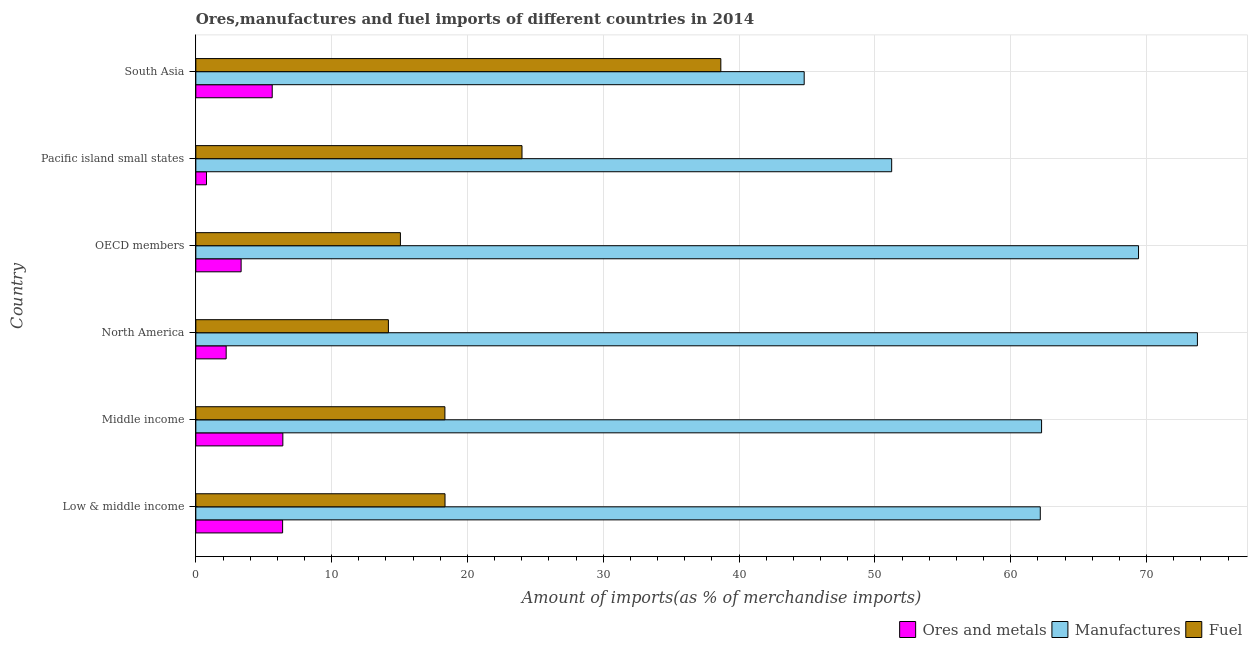How many different coloured bars are there?
Your answer should be very brief. 3. What is the percentage of fuel imports in Pacific island small states?
Your answer should be very brief. 24.01. Across all countries, what is the maximum percentage of ores and metals imports?
Offer a very short reply. 6.41. Across all countries, what is the minimum percentage of ores and metals imports?
Provide a short and direct response. 0.79. In which country was the percentage of manufactures imports minimum?
Provide a short and direct response. South Asia. What is the total percentage of ores and metals imports in the graph?
Make the answer very short. 24.77. What is the difference between the percentage of fuel imports in North America and that in South Asia?
Make the answer very short. -24.48. What is the difference between the percentage of manufactures imports in Middle income and the percentage of ores and metals imports in Low & middle income?
Your response must be concise. 55.88. What is the average percentage of manufactures imports per country?
Keep it short and to the point. 60.6. What is the difference between the percentage of ores and metals imports and percentage of fuel imports in South Asia?
Provide a succinct answer. -33.03. In how many countries, is the percentage of manufactures imports greater than 66 %?
Provide a short and direct response. 2. What is the ratio of the percentage of manufactures imports in Middle income to that in Pacific island small states?
Keep it short and to the point. 1.22. Is the percentage of fuel imports in Low & middle income less than that in OECD members?
Make the answer very short. No. What is the difference between the highest and the second highest percentage of manufactures imports?
Your answer should be very brief. 4.33. What is the difference between the highest and the lowest percentage of fuel imports?
Give a very brief answer. 24.47. Is the sum of the percentage of fuel imports in North America and OECD members greater than the maximum percentage of ores and metals imports across all countries?
Keep it short and to the point. Yes. What does the 2nd bar from the top in OECD members represents?
Ensure brevity in your answer.  Manufactures. What does the 3rd bar from the bottom in Pacific island small states represents?
Keep it short and to the point. Fuel. Is it the case that in every country, the sum of the percentage of ores and metals imports and percentage of manufactures imports is greater than the percentage of fuel imports?
Provide a short and direct response. Yes. How many bars are there?
Provide a succinct answer. 18. Are all the bars in the graph horizontal?
Make the answer very short. Yes. How many countries are there in the graph?
Provide a short and direct response. 6. Are the values on the major ticks of X-axis written in scientific E-notation?
Give a very brief answer. No. Does the graph contain grids?
Your answer should be very brief. Yes. How many legend labels are there?
Your answer should be compact. 3. How are the legend labels stacked?
Your response must be concise. Horizontal. What is the title of the graph?
Give a very brief answer. Ores,manufactures and fuel imports of different countries in 2014. Does "Social Protection and Labor" appear as one of the legend labels in the graph?
Give a very brief answer. No. What is the label or title of the X-axis?
Offer a very short reply. Amount of imports(as % of merchandise imports). What is the Amount of imports(as % of merchandise imports) in Ores and metals in Low & middle income?
Give a very brief answer. 6.39. What is the Amount of imports(as % of merchandise imports) in Manufactures in Low & middle income?
Give a very brief answer. 62.17. What is the Amount of imports(as % of merchandise imports) of Fuel in Low & middle income?
Ensure brevity in your answer.  18.35. What is the Amount of imports(as % of merchandise imports) of Ores and metals in Middle income?
Offer a terse response. 6.41. What is the Amount of imports(as % of merchandise imports) of Manufactures in Middle income?
Offer a very short reply. 62.27. What is the Amount of imports(as % of merchandise imports) in Fuel in Middle income?
Your answer should be very brief. 18.34. What is the Amount of imports(as % of merchandise imports) in Ores and metals in North America?
Provide a short and direct response. 2.23. What is the Amount of imports(as % of merchandise imports) of Manufactures in North America?
Your answer should be very brief. 73.74. What is the Amount of imports(as % of merchandise imports) in Fuel in North America?
Your response must be concise. 14.18. What is the Amount of imports(as % of merchandise imports) in Ores and metals in OECD members?
Offer a terse response. 3.33. What is the Amount of imports(as % of merchandise imports) of Manufactures in OECD members?
Your response must be concise. 69.41. What is the Amount of imports(as % of merchandise imports) in Fuel in OECD members?
Your response must be concise. 15.06. What is the Amount of imports(as % of merchandise imports) of Ores and metals in Pacific island small states?
Your answer should be compact. 0.79. What is the Amount of imports(as % of merchandise imports) of Manufactures in Pacific island small states?
Provide a succinct answer. 51.23. What is the Amount of imports(as % of merchandise imports) in Fuel in Pacific island small states?
Ensure brevity in your answer.  24.01. What is the Amount of imports(as % of merchandise imports) in Ores and metals in South Asia?
Make the answer very short. 5.62. What is the Amount of imports(as % of merchandise imports) of Manufactures in South Asia?
Ensure brevity in your answer.  44.79. What is the Amount of imports(as % of merchandise imports) of Fuel in South Asia?
Your answer should be compact. 38.65. Across all countries, what is the maximum Amount of imports(as % of merchandise imports) of Ores and metals?
Your answer should be compact. 6.41. Across all countries, what is the maximum Amount of imports(as % of merchandise imports) in Manufactures?
Offer a terse response. 73.74. Across all countries, what is the maximum Amount of imports(as % of merchandise imports) of Fuel?
Your answer should be compact. 38.65. Across all countries, what is the minimum Amount of imports(as % of merchandise imports) in Ores and metals?
Provide a short and direct response. 0.79. Across all countries, what is the minimum Amount of imports(as % of merchandise imports) of Manufactures?
Your answer should be very brief. 44.79. Across all countries, what is the minimum Amount of imports(as % of merchandise imports) of Fuel?
Your response must be concise. 14.18. What is the total Amount of imports(as % of merchandise imports) in Ores and metals in the graph?
Ensure brevity in your answer.  24.77. What is the total Amount of imports(as % of merchandise imports) of Manufactures in the graph?
Your answer should be very brief. 363.6. What is the total Amount of imports(as % of merchandise imports) in Fuel in the graph?
Give a very brief answer. 128.59. What is the difference between the Amount of imports(as % of merchandise imports) in Ores and metals in Low & middle income and that in Middle income?
Keep it short and to the point. -0.02. What is the difference between the Amount of imports(as % of merchandise imports) of Manufactures in Low & middle income and that in Middle income?
Provide a succinct answer. -0.1. What is the difference between the Amount of imports(as % of merchandise imports) of Fuel in Low & middle income and that in Middle income?
Your response must be concise. 0.01. What is the difference between the Amount of imports(as % of merchandise imports) of Ores and metals in Low & middle income and that in North America?
Your answer should be compact. 4.15. What is the difference between the Amount of imports(as % of merchandise imports) of Manufactures in Low & middle income and that in North America?
Offer a very short reply. -11.57. What is the difference between the Amount of imports(as % of merchandise imports) in Fuel in Low & middle income and that in North America?
Provide a succinct answer. 4.17. What is the difference between the Amount of imports(as % of merchandise imports) of Ores and metals in Low & middle income and that in OECD members?
Offer a very short reply. 3.05. What is the difference between the Amount of imports(as % of merchandise imports) in Manufactures in Low & middle income and that in OECD members?
Make the answer very short. -7.23. What is the difference between the Amount of imports(as % of merchandise imports) of Fuel in Low & middle income and that in OECD members?
Your answer should be very brief. 3.28. What is the difference between the Amount of imports(as % of merchandise imports) in Ores and metals in Low & middle income and that in Pacific island small states?
Provide a short and direct response. 5.6. What is the difference between the Amount of imports(as % of merchandise imports) of Manufactures in Low & middle income and that in Pacific island small states?
Provide a short and direct response. 10.94. What is the difference between the Amount of imports(as % of merchandise imports) of Fuel in Low & middle income and that in Pacific island small states?
Provide a short and direct response. -5.67. What is the difference between the Amount of imports(as % of merchandise imports) in Ores and metals in Low & middle income and that in South Asia?
Offer a terse response. 0.76. What is the difference between the Amount of imports(as % of merchandise imports) of Manufactures in Low & middle income and that in South Asia?
Provide a short and direct response. 17.38. What is the difference between the Amount of imports(as % of merchandise imports) of Fuel in Low & middle income and that in South Asia?
Provide a short and direct response. -20.31. What is the difference between the Amount of imports(as % of merchandise imports) in Ores and metals in Middle income and that in North America?
Provide a short and direct response. 4.17. What is the difference between the Amount of imports(as % of merchandise imports) of Manufactures in Middle income and that in North America?
Your answer should be very brief. -11.47. What is the difference between the Amount of imports(as % of merchandise imports) of Fuel in Middle income and that in North America?
Your response must be concise. 4.16. What is the difference between the Amount of imports(as % of merchandise imports) of Ores and metals in Middle income and that in OECD members?
Keep it short and to the point. 3.07. What is the difference between the Amount of imports(as % of merchandise imports) of Manufactures in Middle income and that in OECD members?
Offer a terse response. -7.14. What is the difference between the Amount of imports(as % of merchandise imports) in Fuel in Middle income and that in OECD members?
Make the answer very short. 3.28. What is the difference between the Amount of imports(as % of merchandise imports) in Ores and metals in Middle income and that in Pacific island small states?
Ensure brevity in your answer.  5.62. What is the difference between the Amount of imports(as % of merchandise imports) in Manufactures in Middle income and that in Pacific island small states?
Give a very brief answer. 11.04. What is the difference between the Amount of imports(as % of merchandise imports) of Fuel in Middle income and that in Pacific island small states?
Your response must be concise. -5.68. What is the difference between the Amount of imports(as % of merchandise imports) in Ores and metals in Middle income and that in South Asia?
Make the answer very short. 0.78. What is the difference between the Amount of imports(as % of merchandise imports) of Manufactures in Middle income and that in South Asia?
Give a very brief answer. 17.48. What is the difference between the Amount of imports(as % of merchandise imports) in Fuel in Middle income and that in South Asia?
Your answer should be very brief. -20.31. What is the difference between the Amount of imports(as % of merchandise imports) in Ores and metals in North America and that in OECD members?
Make the answer very short. -1.1. What is the difference between the Amount of imports(as % of merchandise imports) of Manufactures in North America and that in OECD members?
Your answer should be compact. 4.33. What is the difference between the Amount of imports(as % of merchandise imports) of Fuel in North America and that in OECD members?
Make the answer very short. -0.88. What is the difference between the Amount of imports(as % of merchandise imports) in Ores and metals in North America and that in Pacific island small states?
Offer a very short reply. 1.45. What is the difference between the Amount of imports(as % of merchandise imports) in Manufactures in North America and that in Pacific island small states?
Make the answer very short. 22.51. What is the difference between the Amount of imports(as % of merchandise imports) in Fuel in North America and that in Pacific island small states?
Provide a succinct answer. -9.84. What is the difference between the Amount of imports(as % of merchandise imports) in Ores and metals in North America and that in South Asia?
Keep it short and to the point. -3.39. What is the difference between the Amount of imports(as % of merchandise imports) in Manufactures in North America and that in South Asia?
Provide a short and direct response. 28.95. What is the difference between the Amount of imports(as % of merchandise imports) in Fuel in North America and that in South Asia?
Provide a short and direct response. -24.47. What is the difference between the Amount of imports(as % of merchandise imports) of Ores and metals in OECD members and that in Pacific island small states?
Keep it short and to the point. 2.55. What is the difference between the Amount of imports(as % of merchandise imports) of Manufactures in OECD members and that in Pacific island small states?
Your answer should be compact. 18.18. What is the difference between the Amount of imports(as % of merchandise imports) in Fuel in OECD members and that in Pacific island small states?
Your answer should be very brief. -8.95. What is the difference between the Amount of imports(as % of merchandise imports) of Ores and metals in OECD members and that in South Asia?
Provide a succinct answer. -2.29. What is the difference between the Amount of imports(as % of merchandise imports) in Manufactures in OECD members and that in South Asia?
Your answer should be very brief. 24.62. What is the difference between the Amount of imports(as % of merchandise imports) of Fuel in OECD members and that in South Asia?
Keep it short and to the point. -23.59. What is the difference between the Amount of imports(as % of merchandise imports) of Ores and metals in Pacific island small states and that in South Asia?
Your answer should be compact. -4.84. What is the difference between the Amount of imports(as % of merchandise imports) in Manufactures in Pacific island small states and that in South Asia?
Your answer should be very brief. 6.44. What is the difference between the Amount of imports(as % of merchandise imports) in Fuel in Pacific island small states and that in South Asia?
Provide a succinct answer. -14.64. What is the difference between the Amount of imports(as % of merchandise imports) in Ores and metals in Low & middle income and the Amount of imports(as % of merchandise imports) in Manufactures in Middle income?
Offer a very short reply. -55.88. What is the difference between the Amount of imports(as % of merchandise imports) in Ores and metals in Low & middle income and the Amount of imports(as % of merchandise imports) in Fuel in Middle income?
Your answer should be very brief. -11.95. What is the difference between the Amount of imports(as % of merchandise imports) of Manufactures in Low & middle income and the Amount of imports(as % of merchandise imports) of Fuel in Middle income?
Your response must be concise. 43.83. What is the difference between the Amount of imports(as % of merchandise imports) of Ores and metals in Low & middle income and the Amount of imports(as % of merchandise imports) of Manufactures in North America?
Offer a very short reply. -67.35. What is the difference between the Amount of imports(as % of merchandise imports) in Ores and metals in Low & middle income and the Amount of imports(as % of merchandise imports) in Fuel in North America?
Provide a succinct answer. -7.79. What is the difference between the Amount of imports(as % of merchandise imports) in Manufactures in Low & middle income and the Amount of imports(as % of merchandise imports) in Fuel in North America?
Provide a succinct answer. 47.99. What is the difference between the Amount of imports(as % of merchandise imports) of Ores and metals in Low & middle income and the Amount of imports(as % of merchandise imports) of Manufactures in OECD members?
Your answer should be very brief. -63.02. What is the difference between the Amount of imports(as % of merchandise imports) of Ores and metals in Low & middle income and the Amount of imports(as % of merchandise imports) of Fuel in OECD members?
Keep it short and to the point. -8.67. What is the difference between the Amount of imports(as % of merchandise imports) of Manufactures in Low & middle income and the Amount of imports(as % of merchandise imports) of Fuel in OECD members?
Give a very brief answer. 47.11. What is the difference between the Amount of imports(as % of merchandise imports) in Ores and metals in Low & middle income and the Amount of imports(as % of merchandise imports) in Manufactures in Pacific island small states?
Your answer should be compact. -44.84. What is the difference between the Amount of imports(as % of merchandise imports) of Ores and metals in Low & middle income and the Amount of imports(as % of merchandise imports) of Fuel in Pacific island small states?
Keep it short and to the point. -17.63. What is the difference between the Amount of imports(as % of merchandise imports) in Manufactures in Low & middle income and the Amount of imports(as % of merchandise imports) in Fuel in Pacific island small states?
Your answer should be compact. 38.16. What is the difference between the Amount of imports(as % of merchandise imports) in Ores and metals in Low & middle income and the Amount of imports(as % of merchandise imports) in Manufactures in South Asia?
Keep it short and to the point. -38.4. What is the difference between the Amount of imports(as % of merchandise imports) of Ores and metals in Low & middle income and the Amount of imports(as % of merchandise imports) of Fuel in South Asia?
Offer a terse response. -32.26. What is the difference between the Amount of imports(as % of merchandise imports) of Manufactures in Low & middle income and the Amount of imports(as % of merchandise imports) of Fuel in South Asia?
Make the answer very short. 23.52. What is the difference between the Amount of imports(as % of merchandise imports) in Ores and metals in Middle income and the Amount of imports(as % of merchandise imports) in Manufactures in North America?
Offer a very short reply. -67.33. What is the difference between the Amount of imports(as % of merchandise imports) of Ores and metals in Middle income and the Amount of imports(as % of merchandise imports) of Fuel in North America?
Ensure brevity in your answer.  -7.77. What is the difference between the Amount of imports(as % of merchandise imports) of Manufactures in Middle income and the Amount of imports(as % of merchandise imports) of Fuel in North America?
Offer a very short reply. 48.09. What is the difference between the Amount of imports(as % of merchandise imports) in Ores and metals in Middle income and the Amount of imports(as % of merchandise imports) in Manufactures in OECD members?
Make the answer very short. -63. What is the difference between the Amount of imports(as % of merchandise imports) in Ores and metals in Middle income and the Amount of imports(as % of merchandise imports) in Fuel in OECD members?
Provide a short and direct response. -8.66. What is the difference between the Amount of imports(as % of merchandise imports) in Manufactures in Middle income and the Amount of imports(as % of merchandise imports) in Fuel in OECD members?
Your response must be concise. 47.21. What is the difference between the Amount of imports(as % of merchandise imports) in Ores and metals in Middle income and the Amount of imports(as % of merchandise imports) in Manufactures in Pacific island small states?
Your answer should be compact. -44.82. What is the difference between the Amount of imports(as % of merchandise imports) in Ores and metals in Middle income and the Amount of imports(as % of merchandise imports) in Fuel in Pacific island small states?
Offer a very short reply. -17.61. What is the difference between the Amount of imports(as % of merchandise imports) of Manufactures in Middle income and the Amount of imports(as % of merchandise imports) of Fuel in Pacific island small states?
Offer a terse response. 38.25. What is the difference between the Amount of imports(as % of merchandise imports) of Ores and metals in Middle income and the Amount of imports(as % of merchandise imports) of Manufactures in South Asia?
Offer a very short reply. -38.38. What is the difference between the Amount of imports(as % of merchandise imports) in Ores and metals in Middle income and the Amount of imports(as % of merchandise imports) in Fuel in South Asia?
Provide a succinct answer. -32.25. What is the difference between the Amount of imports(as % of merchandise imports) of Manufactures in Middle income and the Amount of imports(as % of merchandise imports) of Fuel in South Asia?
Give a very brief answer. 23.61. What is the difference between the Amount of imports(as % of merchandise imports) of Ores and metals in North America and the Amount of imports(as % of merchandise imports) of Manufactures in OECD members?
Make the answer very short. -67.17. What is the difference between the Amount of imports(as % of merchandise imports) of Ores and metals in North America and the Amount of imports(as % of merchandise imports) of Fuel in OECD members?
Offer a very short reply. -12.83. What is the difference between the Amount of imports(as % of merchandise imports) of Manufactures in North America and the Amount of imports(as % of merchandise imports) of Fuel in OECD members?
Your answer should be compact. 58.68. What is the difference between the Amount of imports(as % of merchandise imports) of Ores and metals in North America and the Amount of imports(as % of merchandise imports) of Manufactures in Pacific island small states?
Make the answer very short. -49. What is the difference between the Amount of imports(as % of merchandise imports) in Ores and metals in North America and the Amount of imports(as % of merchandise imports) in Fuel in Pacific island small states?
Offer a terse response. -21.78. What is the difference between the Amount of imports(as % of merchandise imports) in Manufactures in North America and the Amount of imports(as % of merchandise imports) in Fuel in Pacific island small states?
Make the answer very short. 49.73. What is the difference between the Amount of imports(as % of merchandise imports) of Ores and metals in North America and the Amount of imports(as % of merchandise imports) of Manufactures in South Asia?
Your answer should be compact. -42.56. What is the difference between the Amount of imports(as % of merchandise imports) of Ores and metals in North America and the Amount of imports(as % of merchandise imports) of Fuel in South Asia?
Make the answer very short. -36.42. What is the difference between the Amount of imports(as % of merchandise imports) of Manufactures in North America and the Amount of imports(as % of merchandise imports) of Fuel in South Asia?
Offer a terse response. 35.09. What is the difference between the Amount of imports(as % of merchandise imports) of Ores and metals in OECD members and the Amount of imports(as % of merchandise imports) of Manufactures in Pacific island small states?
Provide a succinct answer. -47.9. What is the difference between the Amount of imports(as % of merchandise imports) in Ores and metals in OECD members and the Amount of imports(as % of merchandise imports) in Fuel in Pacific island small states?
Offer a terse response. -20.68. What is the difference between the Amount of imports(as % of merchandise imports) in Manufactures in OECD members and the Amount of imports(as % of merchandise imports) in Fuel in Pacific island small states?
Ensure brevity in your answer.  45.39. What is the difference between the Amount of imports(as % of merchandise imports) of Ores and metals in OECD members and the Amount of imports(as % of merchandise imports) of Manufactures in South Asia?
Ensure brevity in your answer.  -41.45. What is the difference between the Amount of imports(as % of merchandise imports) of Ores and metals in OECD members and the Amount of imports(as % of merchandise imports) of Fuel in South Asia?
Make the answer very short. -35.32. What is the difference between the Amount of imports(as % of merchandise imports) in Manufactures in OECD members and the Amount of imports(as % of merchandise imports) in Fuel in South Asia?
Offer a very short reply. 30.75. What is the difference between the Amount of imports(as % of merchandise imports) of Ores and metals in Pacific island small states and the Amount of imports(as % of merchandise imports) of Manufactures in South Asia?
Keep it short and to the point. -44. What is the difference between the Amount of imports(as % of merchandise imports) in Ores and metals in Pacific island small states and the Amount of imports(as % of merchandise imports) in Fuel in South Asia?
Ensure brevity in your answer.  -37.87. What is the difference between the Amount of imports(as % of merchandise imports) of Manufactures in Pacific island small states and the Amount of imports(as % of merchandise imports) of Fuel in South Asia?
Provide a succinct answer. 12.58. What is the average Amount of imports(as % of merchandise imports) of Ores and metals per country?
Offer a terse response. 4.13. What is the average Amount of imports(as % of merchandise imports) in Manufactures per country?
Your response must be concise. 60.6. What is the average Amount of imports(as % of merchandise imports) of Fuel per country?
Your response must be concise. 21.43. What is the difference between the Amount of imports(as % of merchandise imports) in Ores and metals and Amount of imports(as % of merchandise imports) in Manufactures in Low & middle income?
Your response must be concise. -55.78. What is the difference between the Amount of imports(as % of merchandise imports) in Ores and metals and Amount of imports(as % of merchandise imports) in Fuel in Low & middle income?
Your response must be concise. -11.96. What is the difference between the Amount of imports(as % of merchandise imports) of Manufactures and Amount of imports(as % of merchandise imports) of Fuel in Low & middle income?
Your response must be concise. 43.83. What is the difference between the Amount of imports(as % of merchandise imports) in Ores and metals and Amount of imports(as % of merchandise imports) in Manufactures in Middle income?
Give a very brief answer. -55.86. What is the difference between the Amount of imports(as % of merchandise imports) of Ores and metals and Amount of imports(as % of merchandise imports) of Fuel in Middle income?
Give a very brief answer. -11.93. What is the difference between the Amount of imports(as % of merchandise imports) of Manufactures and Amount of imports(as % of merchandise imports) of Fuel in Middle income?
Your answer should be very brief. 43.93. What is the difference between the Amount of imports(as % of merchandise imports) of Ores and metals and Amount of imports(as % of merchandise imports) of Manufactures in North America?
Your answer should be very brief. -71.51. What is the difference between the Amount of imports(as % of merchandise imports) in Ores and metals and Amount of imports(as % of merchandise imports) in Fuel in North America?
Provide a succinct answer. -11.94. What is the difference between the Amount of imports(as % of merchandise imports) of Manufactures and Amount of imports(as % of merchandise imports) of Fuel in North America?
Offer a very short reply. 59.56. What is the difference between the Amount of imports(as % of merchandise imports) in Ores and metals and Amount of imports(as % of merchandise imports) in Manufactures in OECD members?
Provide a short and direct response. -66.07. What is the difference between the Amount of imports(as % of merchandise imports) in Ores and metals and Amount of imports(as % of merchandise imports) in Fuel in OECD members?
Give a very brief answer. -11.73. What is the difference between the Amount of imports(as % of merchandise imports) of Manufactures and Amount of imports(as % of merchandise imports) of Fuel in OECD members?
Ensure brevity in your answer.  54.34. What is the difference between the Amount of imports(as % of merchandise imports) of Ores and metals and Amount of imports(as % of merchandise imports) of Manufactures in Pacific island small states?
Provide a succinct answer. -50.44. What is the difference between the Amount of imports(as % of merchandise imports) of Ores and metals and Amount of imports(as % of merchandise imports) of Fuel in Pacific island small states?
Make the answer very short. -23.23. What is the difference between the Amount of imports(as % of merchandise imports) of Manufactures and Amount of imports(as % of merchandise imports) of Fuel in Pacific island small states?
Your answer should be very brief. 27.22. What is the difference between the Amount of imports(as % of merchandise imports) of Ores and metals and Amount of imports(as % of merchandise imports) of Manufactures in South Asia?
Your answer should be very brief. -39.16. What is the difference between the Amount of imports(as % of merchandise imports) in Ores and metals and Amount of imports(as % of merchandise imports) in Fuel in South Asia?
Make the answer very short. -33.03. What is the difference between the Amount of imports(as % of merchandise imports) in Manufactures and Amount of imports(as % of merchandise imports) in Fuel in South Asia?
Make the answer very short. 6.14. What is the ratio of the Amount of imports(as % of merchandise imports) in Manufactures in Low & middle income to that in Middle income?
Make the answer very short. 1. What is the ratio of the Amount of imports(as % of merchandise imports) in Fuel in Low & middle income to that in Middle income?
Ensure brevity in your answer.  1. What is the ratio of the Amount of imports(as % of merchandise imports) of Ores and metals in Low & middle income to that in North America?
Your response must be concise. 2.86. What is the ratio of the Amount of imports(as % of merchandise imports) of Manufactures in Low & middle income to that in North America?
Give a very brief answer. 0.84. What is the ratio of the Amount of imports(as % of merchandise imports) of Fuel in Low & middle income to that in North America?
Give a very brief answer. 1.29. What is the ratio of the Amount of imports(as % of merchandise imports) in Ores and metals in Low & middle income to that in OECD members?
Keep it short and to the point. 1.92. What is the ratio of the Amount of imports(as % of merchandise imports) in Manufactures in Low & middle income to that in OECD members?
Keep it short and to the point. 0.9. What is the ratio of the Amount of imports(as % of merchandise imports) in Fuel in Low & middle income to that in OECD members?
Make the answer very short. 1.22. What is the ratio of the Amount of imports(as % of merchandise imports) of Ores and metals in Low & middle income to that in Pacific island small states?
Offer a terse response. 8.13. What is the ratio of the Amount of imports(as % of merchandise imports) in Manufactures in Low & middle income to that in Pacific island small states?
Ensure brevity in your answer.  1.21. What is the ratio of the Amount of imports(as % of merchandise imports) of Fuel in Low & middle income to that in Pacific island small states?
Keep it short and to the point. 0.76. What is the ratio of the Amount of imports(as % of merchandise imports) of Ores and metals in Low & middle income to that in South Asia?
Your answer should be compact. 1.14. What is the ratio of the Amount of imports(as % of merchandise imports) in Manufactures in Low & middle income to that in South Asia?
Make the answer very short. 1.39. What is the ratio of the Amount of imports(as % of merchandise imports) of Fuel in Low & middle income to that in South Asia?
Provide a succinct answer. 0.47. What is the ratio of the Amount of imports(as % of merchandise imports) of Ores and metals in Middle income to that in North America?
Provide a succinct answer. 2.87. What is the ratio of the Amount of imports(as % of merchandise imports) in Manufactures in Middle income to that in North America?
Offer a terse response. 0.84. What is the ratio of the Amount of imports(as % of merchandise imports) in Fuel in Middle income to that in North America?
Offer a terse response. 1.29. What is the ratio of the Amount of imports(as % of merchandise imports) in Ores and metals in Middle income to that in OECD members?
Give a very brief answer. 1.92. What is the ratio of the Amount of imports(as % of merchandise imports) of Manufactures in Middle income to that in OECD members?
Give a very brief answer. 0.9. What is the ratio of the Amount of imports(as % of merchandise imports) in Fuel in Middle income to that in OECD members?
Ensure brevity in your answer.  1.22. What is the ratio of the Amount of imports(as % of merchandise imports) of Ores and metals in Middle income to that in Pacific island small states?
Your answer should be compact. 8.15. What is the ratio of the Amount of imports(as % of merchandise imports) of Manufactures in Middle income to that in Pacific island small states?
Provide a short and direct response. 1.22. What is the ratio of the Amount of imports(as % of merchandise imports) in Fuel in Middle income to that in Pacific island small states?
Provide a succinct answer. 0.76. What is the ratio of the Amount of imports(as % of merchandise imports) of Ores and metals in Middle income to that in South Asia?
Keep it short and to the point. 1.14. What is the ratio of the Amount of imports(as % of merchandise imports) of Manufactures in Middle income to that in South Asia?
Your response must be concise. 1.39. What is the ratio of the Amount of imports(as % of merchandise imports) of Fuel in Middle income to that in South Asia?
Give a very brief answer. 0.47. What is the ratio of the Amount of imports(as % of merchandise imports) of Ores and metals in North America to that in OECD members?
Your response must be concise. 0.67. What is the ratio of the Amount of imports(as % of merchandise imports) in Fuel in North America to that in OECD members?
Offer a terse response. 0.94. What is the ratio of the Amount of imports(as % of merchandise imports) in Ores and metals in North America to that in Pacific island small states?
Your answer should be very brief. 2.84. What is the ratio of the Amount of imports(as % of merchandise imports) of Manufactures in North America to that in Pacific island small states?
Your response must be concise. 1.44. What is the ratio of the Amount of imports(as % of merchandise imports) of Fuel in North America to that in Pacific island small states?
Make the answer very short. 0.59. What is the ratio of the Amount of imports(as % of merchandise imports) of Ores and metals in North America to that in South Asia?
Provide a short and direct response. 0.4. What is the ratio of the Amount of imports(as % of merchandise imports) of Manufactures in North America to that in South Asia?
Keep it short and to the point. 1.65. What is the ratio of the Amount of imports(as % of merchandise imports) of Fuel in North America to that in South Asia?
Provide a short and direct response. 0.37. What is the ratio of the Amount of imports(as % of merchandise imports) in Ores and metals in OECD members to that in Pacific island small states?
Ensure brevity in your answer.  4.24. What is the ratio of the Amount of imports(as % of merchandise imports) of Manufactures in OECD members to that in Pacific island small states?
Make the answer very short. 1.35. What is the ratio of the Amount of imports(as % of merchandise imports) of Fuel in OECD members to that in Pacific island small states?
Provide a short and direct response. 0.63. What is the ratio of the Amount of imports(as % of merchandise imports) in Ores and metals in OECD members to that in South Asia?
Give a very brief answer. 0.59. What is the ratio of the Amount of imports(as % of merchandise imports) in Manufactures in OECD members to that in South Asia?
Keep it short and to the point. 1.55. What is the ratio of the Amount of imports(as % of merchandise imports) in Fuel in OECD members to that in South Asia?
Your response must be concise. 0.39. What is the ratio of the Amount of imports(as % of merchandise imports) in Ores and metals in Pacific island small states to that in South Asia?
Ensure brevity in your answer.  0.14. What is the ratio of the Amount of imports(as % of merchandise imports) of Manufactures in Pacific island small states to that in South Asia?
Provide a short and direct response. 1.14. What is the ratio of the Amount of imports(as % of merchandise imports) of Fuel in Pacific island small states to that in South Asia?
Keep it short and to the point. 0.62. What is the difference between the highest and the second highest Amount of imports(as % of merchandise imports) in Ores and metals?
Your answer should be compact. 0.02. What is the difference between the highest and the second highest Amount of imports(as % of merchandise imports) of Manufactures?
Provide a succinct answer. 4.33. What is the difference between the highest and the second highest Amount of imports(as % of merchandise imports) of Fuel?
Offer a very short reply. 14.64. What is the difference between the highest and the lowest Amount of imports(as % of merchandise imports) in Ores and metals?
Your answer should be very brief. 5.62. What is the difference between the highest and the lowest Amount of imports(as % of merchandise imports) in Manufactures?
Offer a terse response. 28.95. What is the difference between the highest and the lowest Amount of imports(as % of merchandise imports) in Fuel?
Your answer should be very brief. 24.47. 